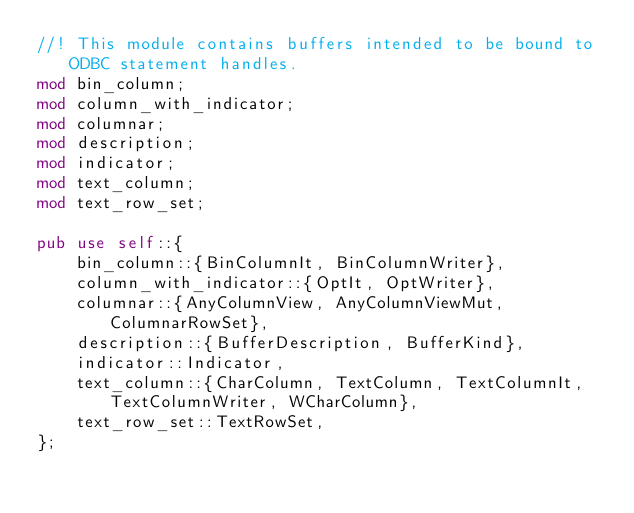Convert code to text. <code><loc_0><loc_0><loc_500><loc_500><_Rust_>//! This module contains buffers intended to be bound to ODBC statement handles.
mod bin_column;
mod column_with_indicator;
mod columnar;
mod description;
mod indicator;
mod text_column;
mod text_row_set;

pub use self::{
    bin_column::{BinColumnIt, BinColumnWriter},
    column_with_indicator::{OptIt, OptWriter},
    columnar::{AnyColumnView, AnyColumnViewMut, ColumnarRowSet},
    description::{BufferDescription, BufferKind},
    indicator::Indicator,
    text_column::{CharColumn, TextColumn, TextColumnIt, TextColumnWriter, WCharColumn},
    text_row_set::TextRowSet,
};
</code> 